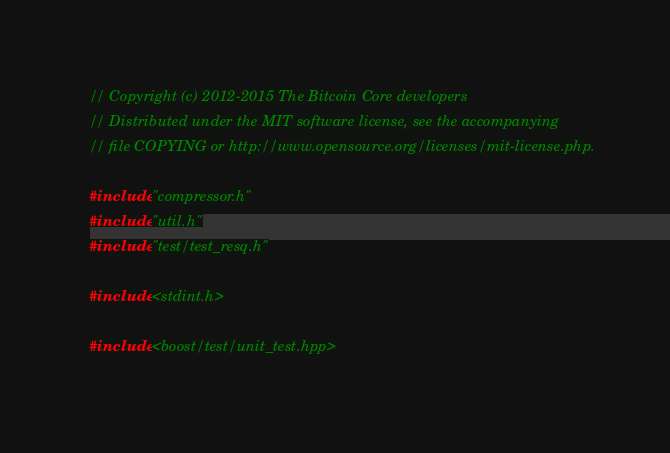Convert code to text. <code><loc_0><loc_0><loc_500><loc_500><_C++_>// Copyright (c) 2012-2015 The Bitcoin Core developers
// Distributed under the MIT software license, see the accompanying
// file COPYING or http://www.opensource.org/licenses/mit-license.php.

#include "compressor.h"
#include "util.h"
#include "test/test_resq.h"

#include <stdint.h>

#include <boost/test/unit_test.hpp>
</code> 